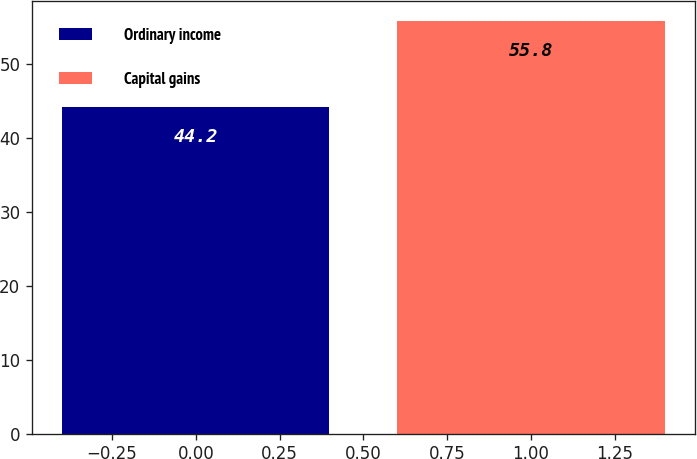Convert chart. <chart><loc_0><loc_0><loc_500><loc_500><bar_chart><fcel>Ordinary income<fcel>Capital gains<nl><fcel>44.2<fcel>55.8<nl></chart> 